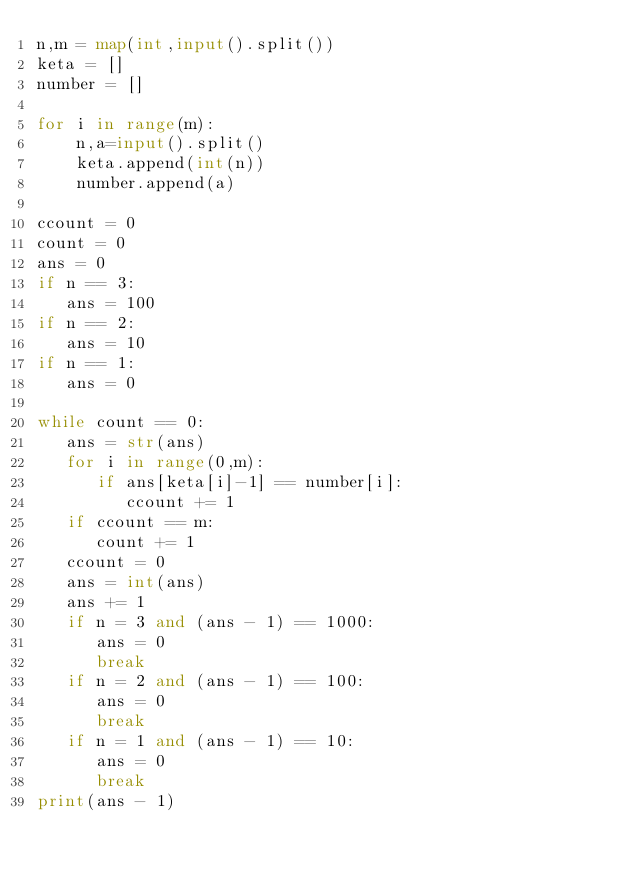<code> <loc_0><loc_0><loc_500><loc_500><_Python_>n,m = map(int,input().split())
keta = []
number = []

for i in range(m):
    n,a=input().split()
    keta.append(int(n))
    number.append(a)

ccount = 0
count = 0   
ans = 0
if n == 3:
   ans = 100
if n == 2:
   ans = 10
if n == 1:
   ans = 0

while count == 0:
   ans = str(ans)
   for i in range(0,m):
      if ans[keta[i]-1] == number[i]:
         ccount += 1
   if ccount == m:
      count += 1
   ccount = 0
   ans = int(ans)
   ans += 1
   if n = 3 and (ans - 1) == 1000:
      ans = 0
      break
   if n = 2 and (ans - 1) == 100:
      ans = 0
      break
   if n = 1 and (ans - 1) == 10:
      ans = 0
      break
print(ans - 1)</code> 